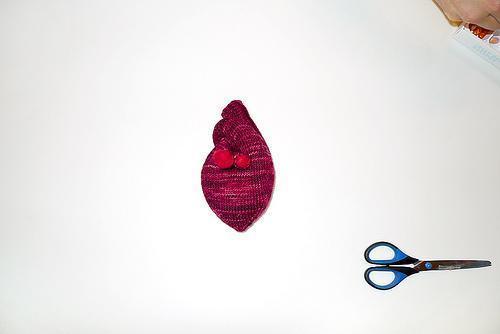How many balls are shown on the purple object in the middle of the photo?
Give a very brief answer. 2. How many finger holes does the scissors have?
Give a very brief answer. 2. How many hands are visible?
Give a very brief answer. 1. How many cars does the train have?
Give a very brief answer. 0. 